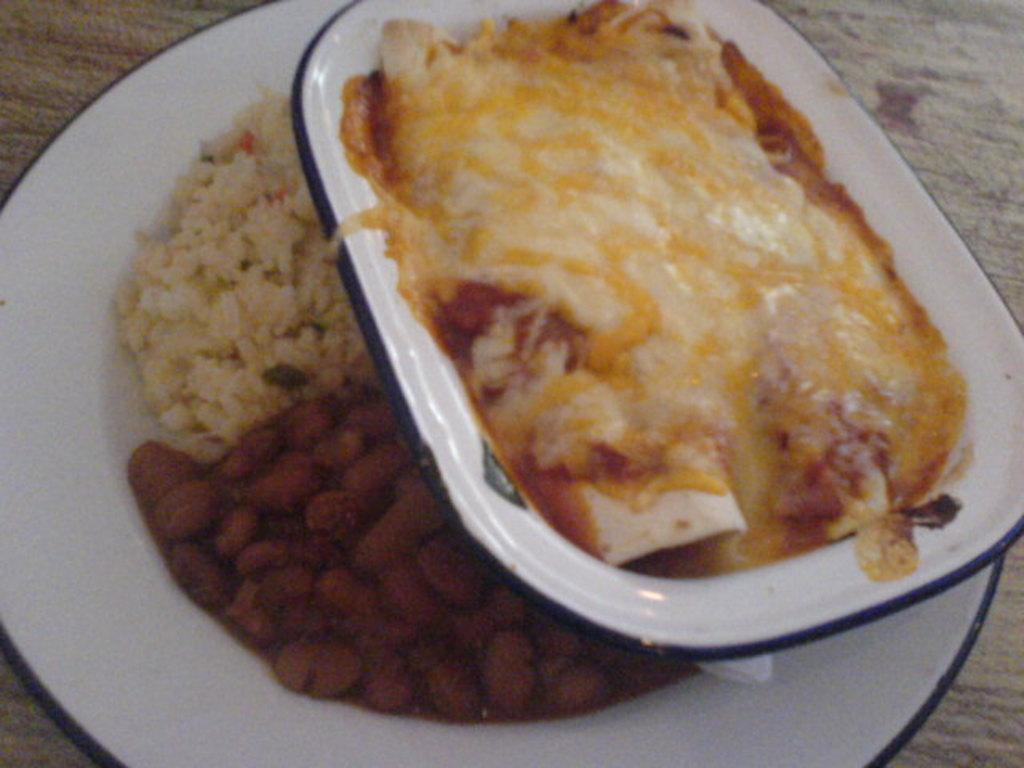What types of food items can be seen in the image? There are three types of food items in the image. How are the food items arranged or presented? The food items are served on a plate. What is the surface on which the plate is placed? The plate is placed on a wooden surface. How many toes can be seen on the servant in the image? There is no servant present in the image, and therefore no toes can be seen. 